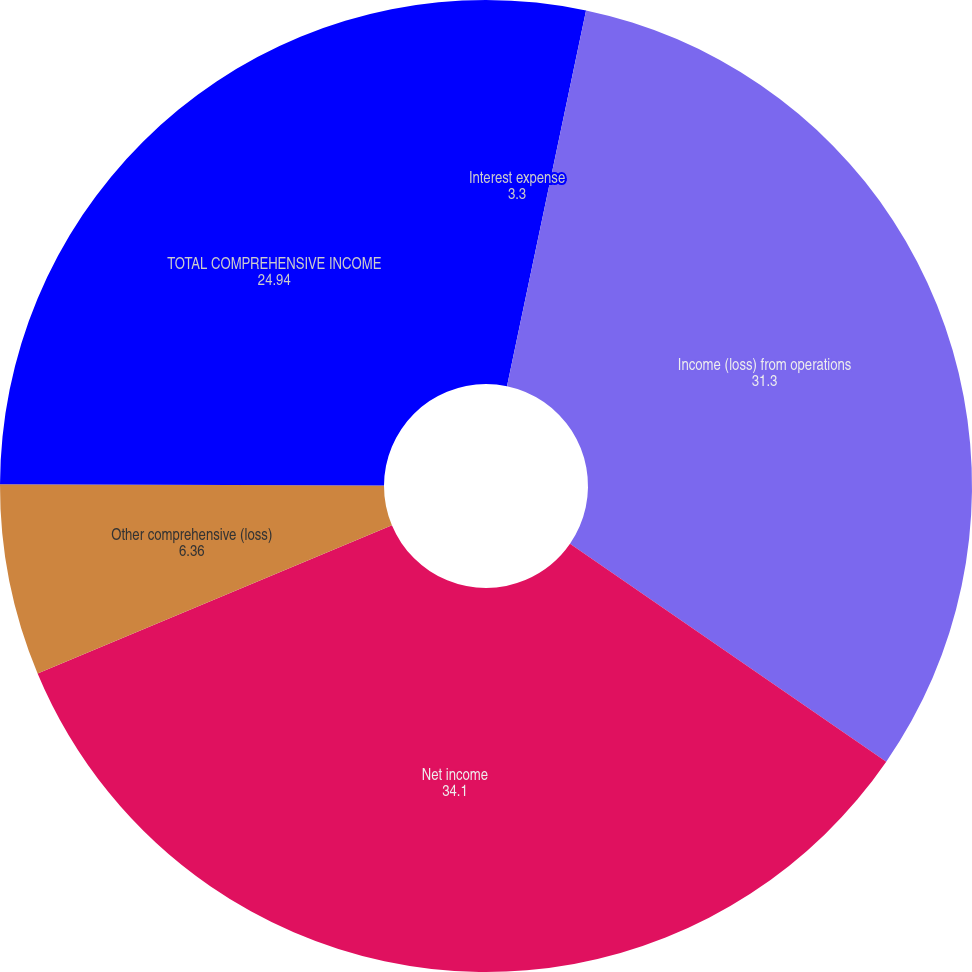Convert chart to OTSL. <chart><loc_0><loc_0><loc_500><loc_500><pie_chart><fcel>Interest expense<fcel>Income (loss) from operations<fcel>Net income<fcel>Other comprehensive (loss)<fcel>TOTAL COMPREHENSIVE INCOME<nl><fcel>3.3%<fcel>31.3%<fcel>34.1%<fcel>6.36%<fcel>24.94%<nl></chart> 